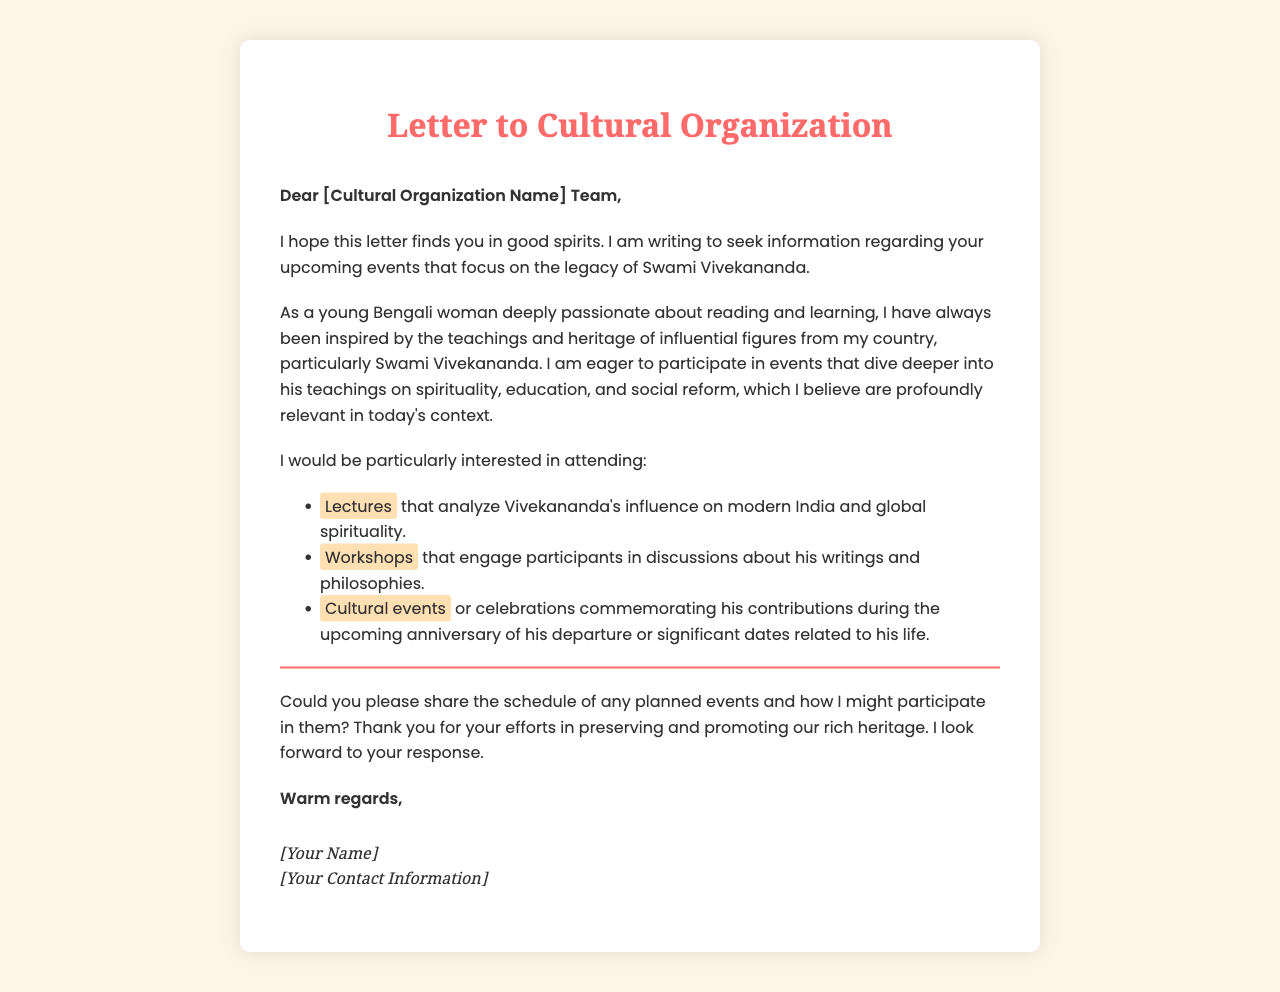What is the primary purpose of the letter? The primary purpose is to seek information about upcoming events focused on Swami Vivekananda's legacy.
Answer: Seek information about upcoming events Who is the letter addressed to? The letter is addressed to a cultural organization, as indicated in the salutation.
Answer: Cultural Organization Name What is the writer's main area of interest regarding Swami Vivekananda? The writer is interested in events that explore Vivekananda's teachings on spirituality, education, and social reform.
Answer: Spirituality, education, and social reform Name one type of event the writer is interested in attending. The writer expresses interest in attending lectures, workshops, or cultural events.
Answer: Lectures What specific aspect of Vivekananda's influence does the writer want to analyze? The writer wants to analyze Vivekananda's influence on modern India and global spirituality during lectures.
Answer: Modern India and global spirituality What type of cultural events does the writer mention? The writer mentions cultural events commemorating Vivekananda's contributions during his anniversary or significant dates.
Answer: Commemorating his contributions What does the writer ask for at the end of the letter? The writer requests the schedule of planned events and participation details.
Answer: Schedule of planned events How does the writer sign off the letter? The writer signs off with "Warm regards," which is a common closing.
Answer: Warm regards What is the style of the letter's body? The body of the letter features a friendly and eager tone as the writer expresses enthusiasm.
Answer: Friendly and eager tone 